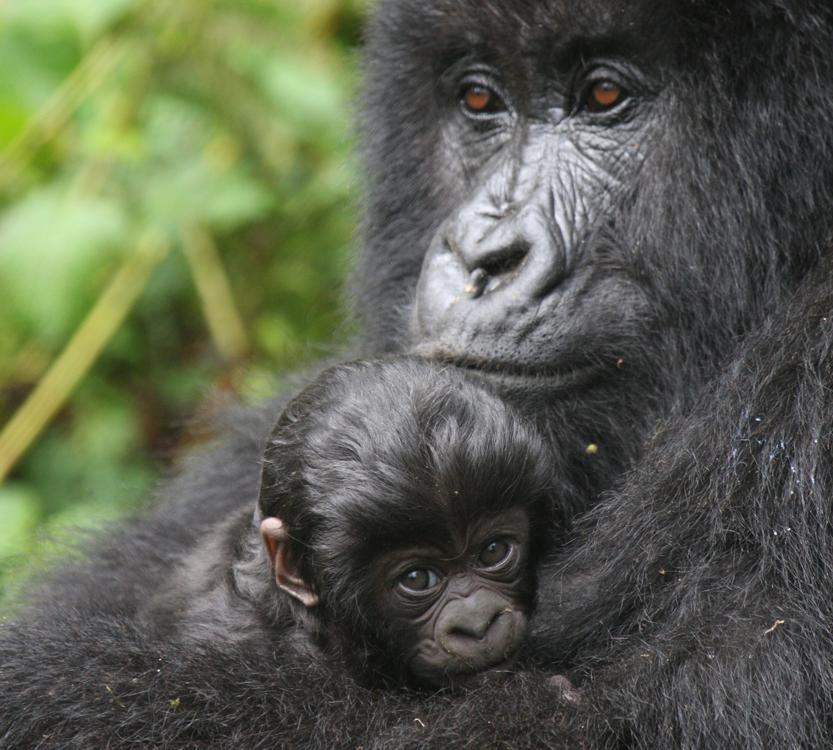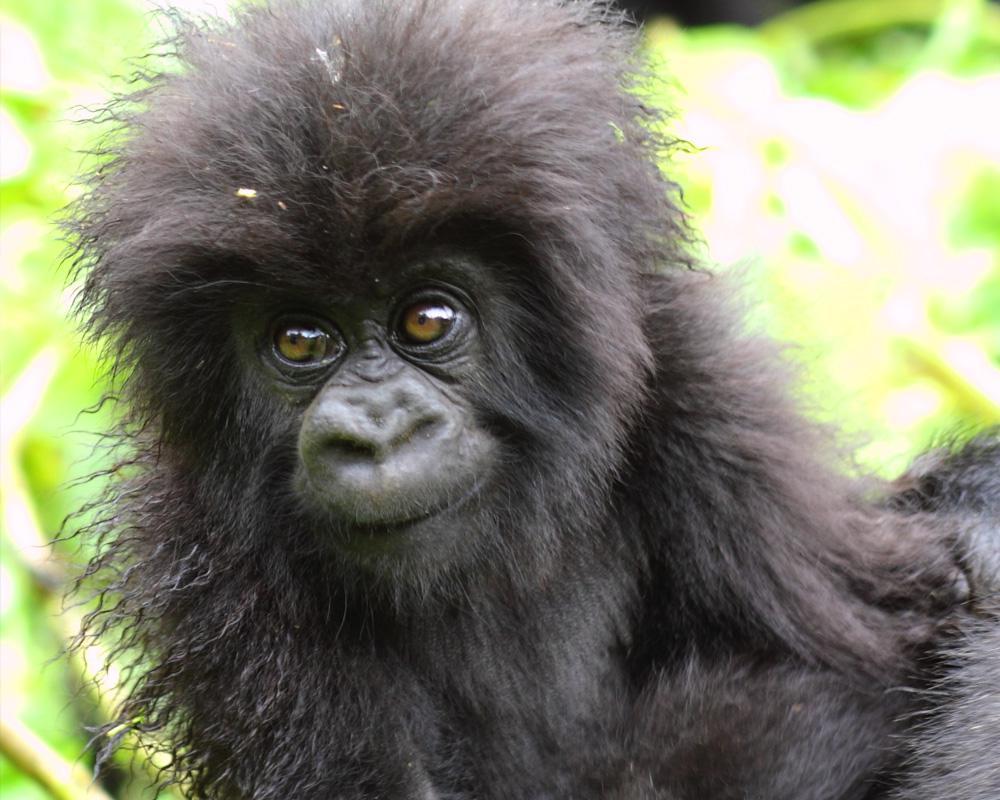The first image is the image on the left, the second image is the image on the right. Evaluate the accuracy of this statement regarding the images: "The right image contains only a baby gorilla with a shock of hair on its head, and the left image includes a baby gorilla on the front of an adult gorilla.". Is it true? Answer yes or no. Yes. The first image is the image on the left, the second image is the image on the right. Given the left and right images, does the statement "In one image is an adult gorilla alone." hold true? Answer yes or no. No. 